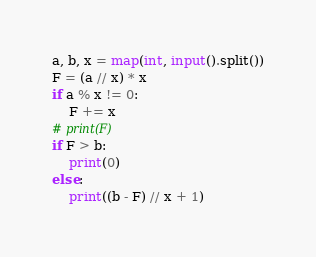<code> <loc_0><loc_0><loc_500><loc_500><_Python_>a, b, x = map(int, input().split())
F = (a // x) * x
if a % x != 0:
    F += x
# print(F)
if F > b:
    print(0)
else:
    print((b - F) // x + 1)
</code> 